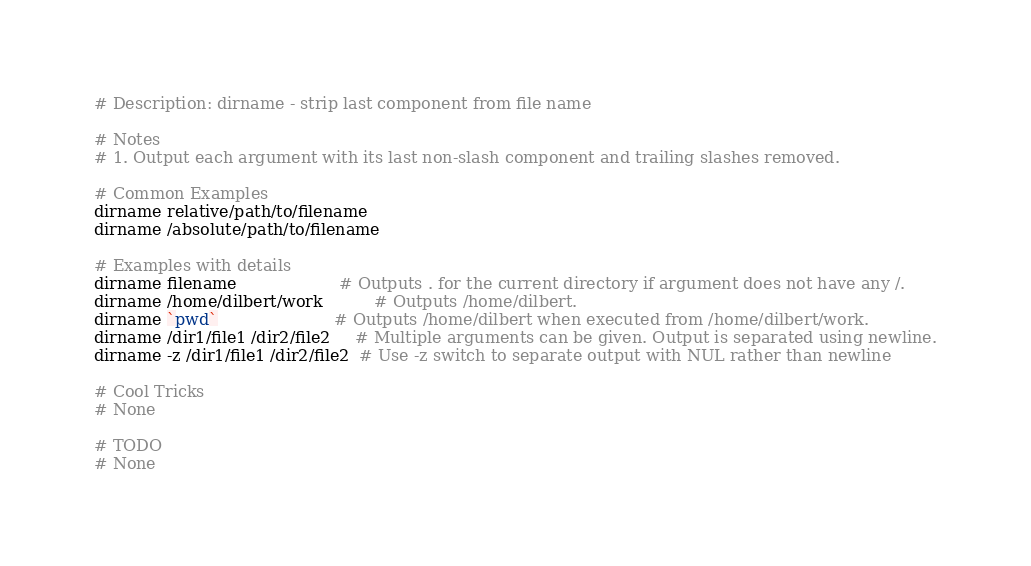<code> <loc_0><loc_0><loc_500><loc_500><_Bash_># Description: dirname - strip last component from file name

# Notes
# 1. Output each argument with its last non-slash component and trailing slashes removed.

# Common Examples
dirname relative/path/to/filename
dirname /absolute/path/to/filename

# Examples with details
dirname filename                    # Outputs . for the current directory if argument does not have any /.
dirname /home/dilbert/work          # Outputs /home/dilbert.
dirname `pwd`                       # Outputs /home/dilbert when executed from /home/dilbert/work.
dirname /dir1/file1 /dir2/file2     # Multiple arguments can be given. Output is separated using newline.
dirname -z /dir1/file1 /dir2/file2  # Use -z switch to separate output with NUL rather than newline

# Cool Tricks
# None

# TODO
# None
</code> 